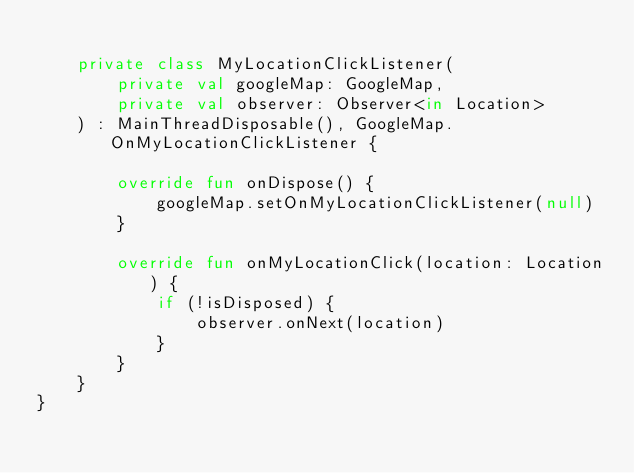Convert code to text. <code><loc_0><loc_0><loc_500><loc_500><_Kotlin_>
    private class MyLocationClickListener(
        private val googleMap: GoogleMap,
        private val observer: Observer<in Location>
    ) : MainThreadDisposable(), GoogleMap.OnMyLocationClickListener {

        override fun onDispose() {
            googleMap.setOnMyLocationClickListener(null)
        }

        override fun onMyLocationClick(location: Location) {
            if (!isDisposed) {
                observer.onNext(location)
            }
        }
    }
}
</code> 